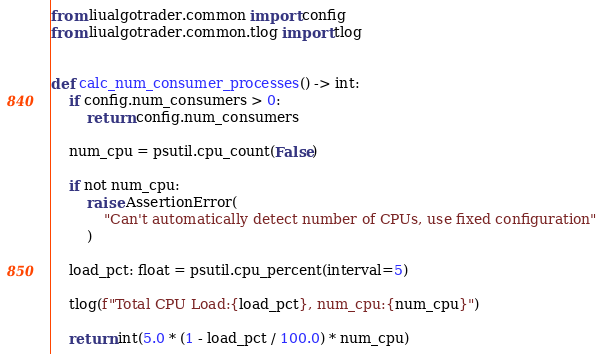<code> <loc_0><loc_0><loc_500><loc_500><_Python_>
from liualgotrader.common import config
from liualgotrader.common.tlog import tlog


def calc_num_consumer_processes() -> int:
    if config.num_consumers > 0:
        return config.num_consumers

    num_cpu = psutil.cpu_count(False)

    if not num_cpu:
        raise AssertionError(
            "Can't automatically detect number of CPUs, use fixed configuration"
        )

    load_pct: float = psutil.cpu_percent(interval=5)

    tlog(f"Total CPU Load:{load_pct}, num_cpu:{num_cpu}")

    return int(5.0 * (1 - load_pct / 100.0) * num_cpu)
</code> 